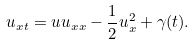Convert formula to latex. <formula><loc_0><loc_0><loc_500><loc_500>u _ { x t } = u u _ { x x } - \frac { 1 } { 2 } u _ { x } ^ { 2 } + \gamma ( t ) .</formula> 